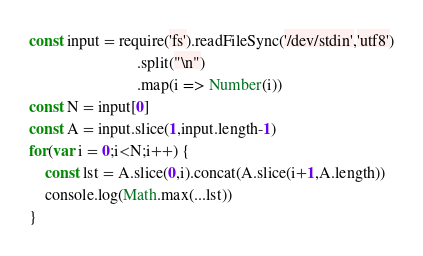<code> <loc_0><loc_0><loc_500><loc_500><_JavaScript_>const input = require('fs').readFileSync('/dev/stdin','utf8')
                           .split("\n")
                           .map(i => Number(i))
const N = input[0]
const A = input.slice(1,input.length-1)
for(var i = 0;i<N;i++) {
    const lst = A.slice(0,i).concat(A.slice(i+1,A.length))
    console.log(Math.max(...lst))
}</code> 